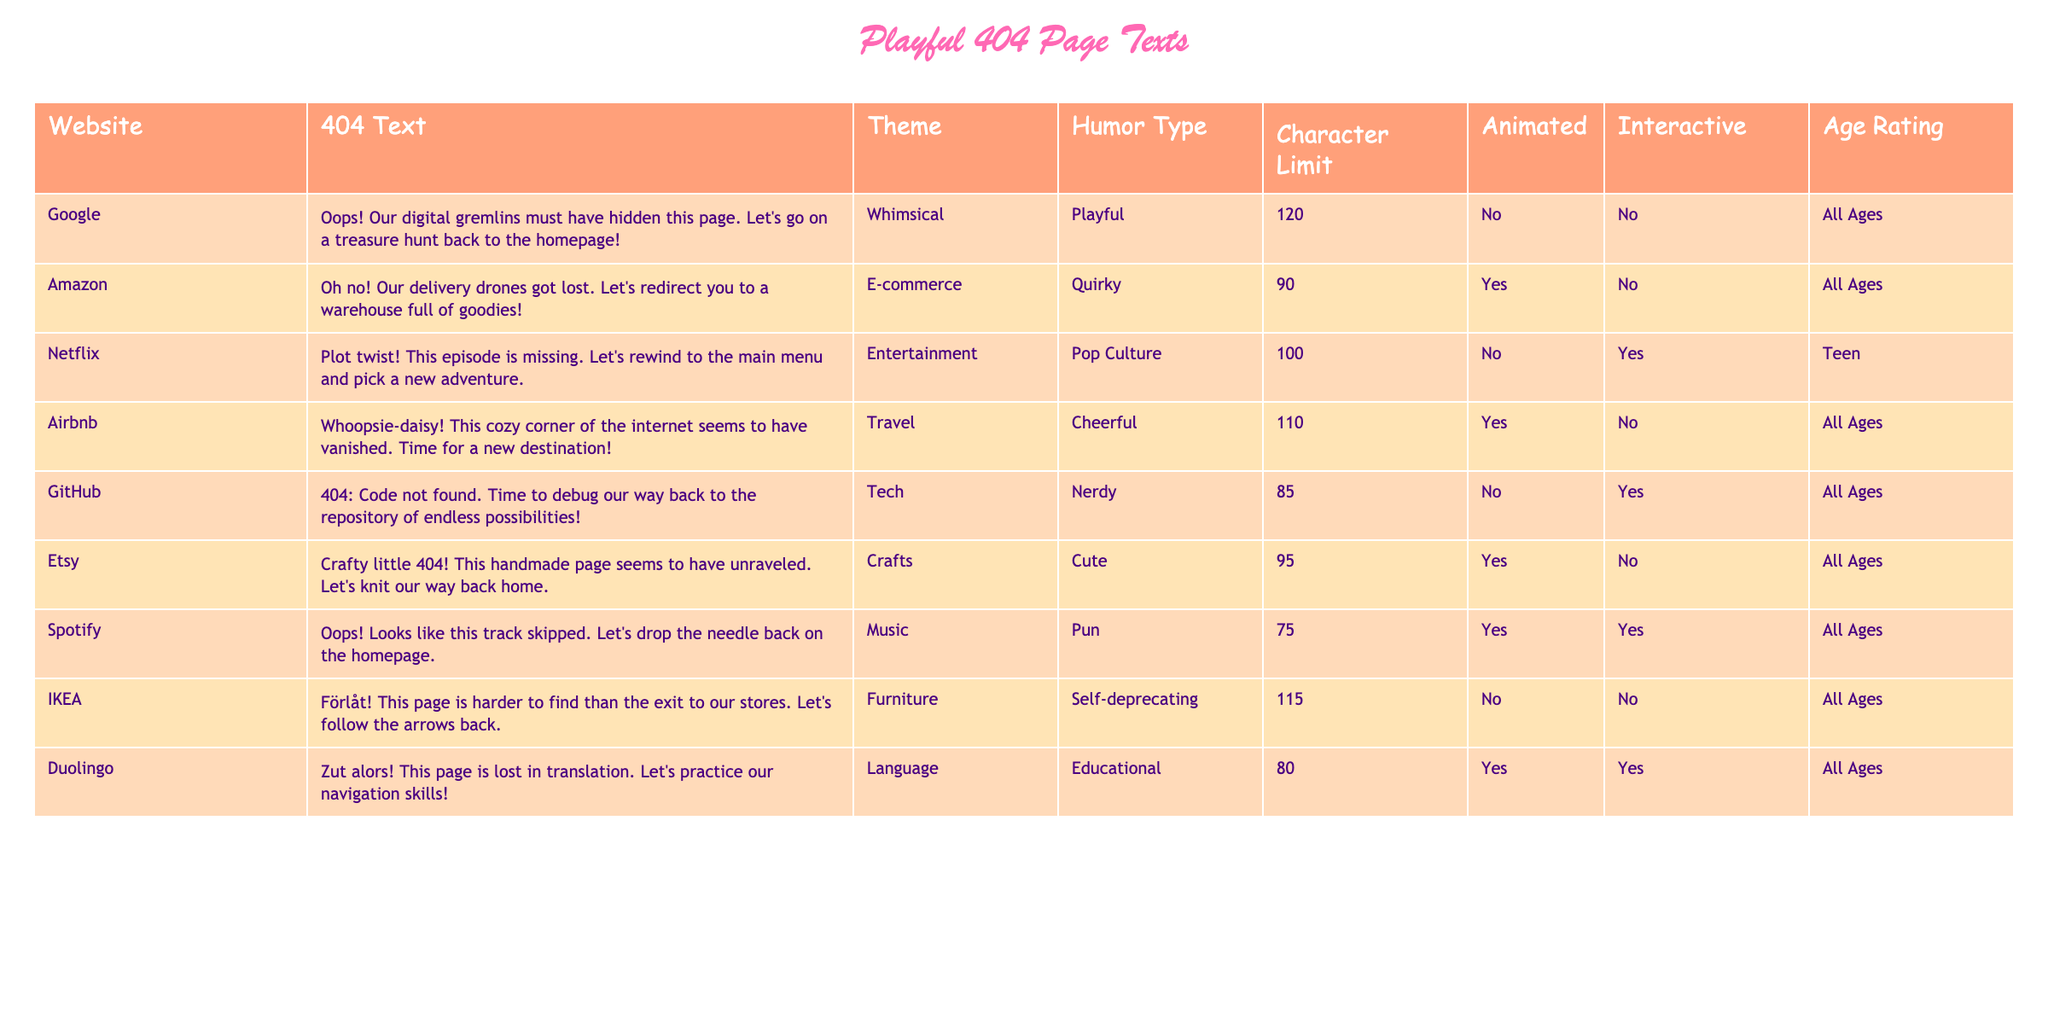What is the playful 404 text from Spotify? The table lists the playful 404 text for Spotify as "Oops! Looks like this track skipped. Let's drop the needle back on the homepage."
Answer: Oops! Looks like this track skipped. Let's drop the needle back on the homepage Which website has an age rating of "Teen"? By checking the age rating column, GitHub and Netflix are the only websites listed with an age rating of "Teen".
Answer: Netflix How many websites have animated 404 texts? By counting the entries in the animated column marked as "Yes", we find that there are 5 websites with animated 404 texts (Amazon, Airbnb, Etsy, Spotify, Duolingo).
Answer: 5 What is the theme of Airbnb's 404 page? The table directly states that the theme for Airbnb's 404 page is "Travel".
Answer: Travel Which website has the longest character limit for its 404 text? By comparing the character limits in the table, Google has the longest character limit of 120 characters.
Answer: Google Are there any websites with self-deprecating humor? Looking at the humor type column, we find that the only website with self-deprecating humor is IKEA.
Answer: Yes What is the average character limit of the websites listed in the table? To find the average, we sum all character limits (120 + 90 + 100 + 110 + 85 + 95 + 75 + 115 + 80) = 1005, and since there are 9 websites, the average is 1005 / 9 = 111.67, which rounds down to 112 for a neat approximation.
Answer: 112 Is there a website that combines playful humor and an animated 404 text? By checking both columns for "Playful" humor types and "Yes" for animated, we see websites like Amazon, Airbnb, Etsy, and Spotify meet both of these criteria.
Answer: Yes Which humor type is associated with the 404 text of GitHub? The humor type associated with the 404 text of GitHub is "Nerdy".
Answer: Nerdy Which website's 404 text suggests going back to the homepage because of "delivery drones"? The playful 404 text from Amazon contains a mention of "delivery drones" and suggests going back to a warehouse full of goodies.
Answer: Amazon 